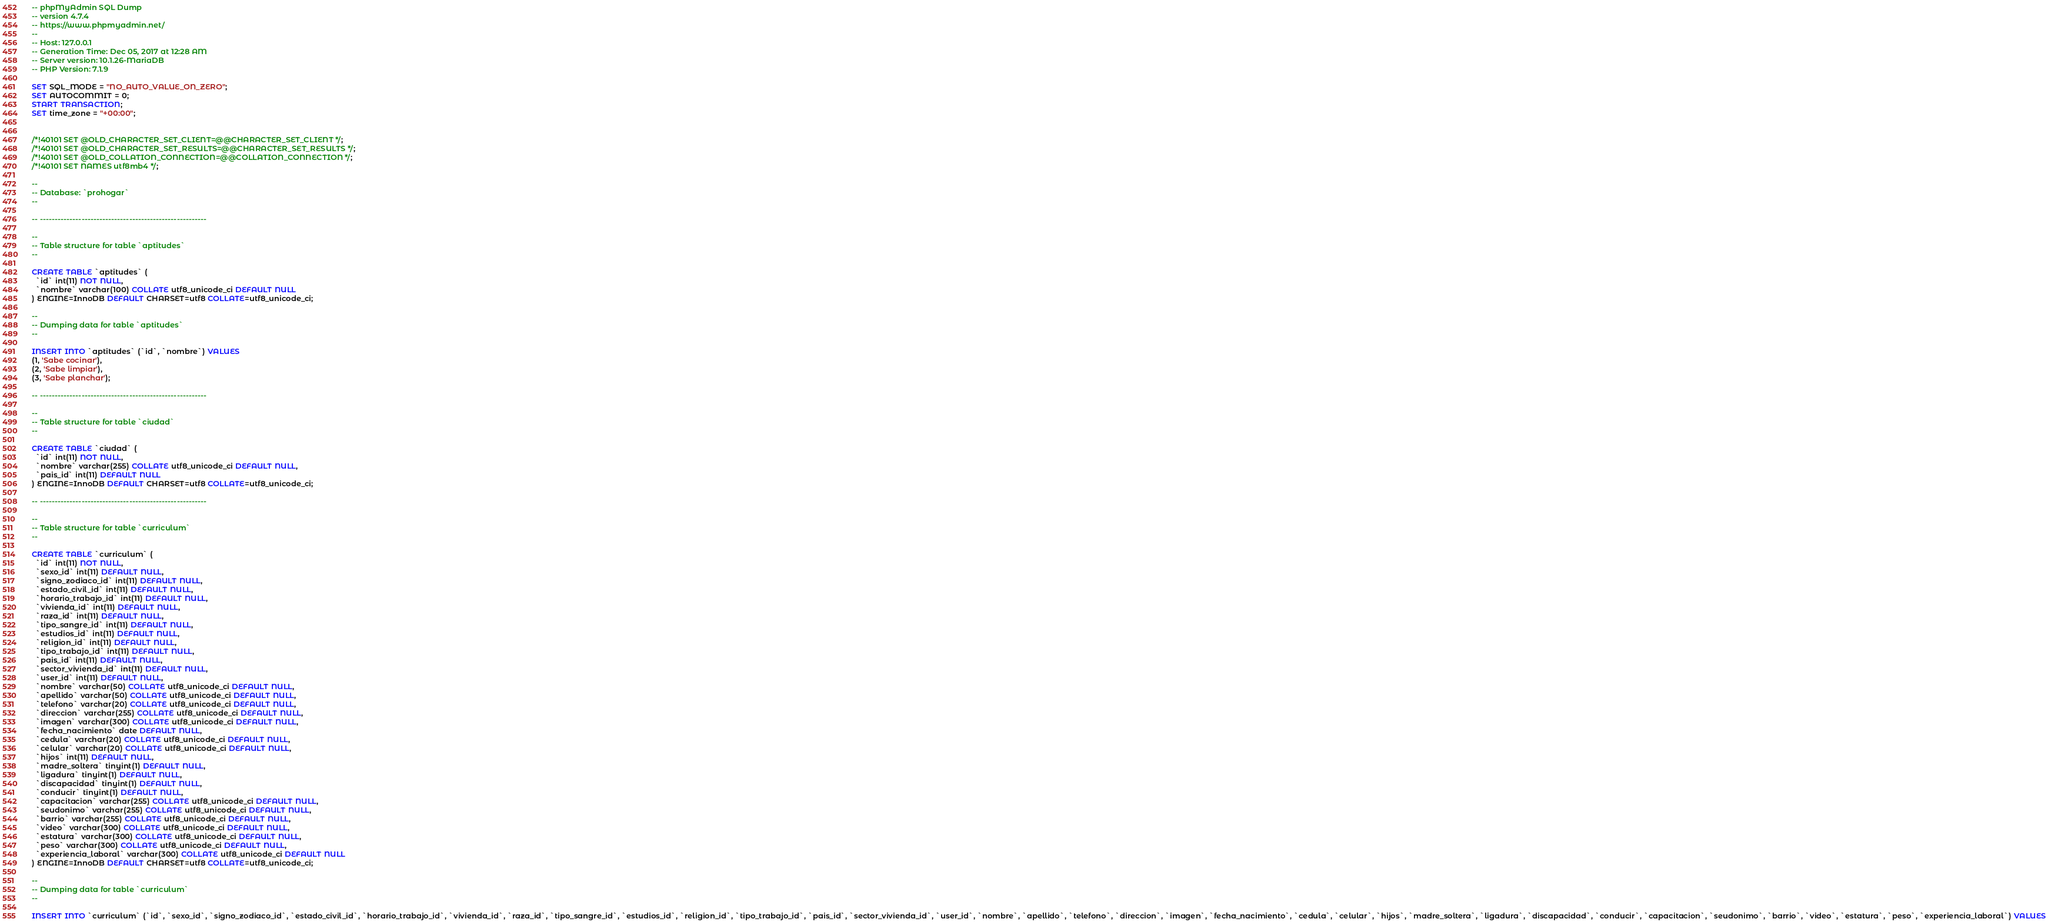<code> <loc_0><loc_0><loc_500><loc_500><_SQL_>-- phpMyAdmin SQL Dump
-- version 4.7.4
-- https://www.phpmyadmin.net/
--
-- Host: 127.0.0.1
-- Generation Time: Dec 05, 2017 at 12:28 AM
-- Server version: 10.1.26-MariaDB
-- PHP Version: 7.1.9

SET SQL_MODE = "NO_AUTO_VALUE_ON_ZERO";
SET AUTOCOMMIT = 0;
START TRANSACTION;
SET time_zone = "+00:00";


/*!40101 SET @OLD_CHARACTER_SET_CLIENT=@@CHARACTER_SET_CLIENT */;
/*!40101 SET @OLD_CHARACTER_SET_RESULTS=@@CHARACTER_SET_RESULTS */;
/*!40101 SET @OLD_COLLATION_CONNECTION=@@COLLATION_CONNECTION */;
/*!40101 SET NAMES utf8mb4 */;

--
-- Database: `prohogar`
--

-- --------------------------------------------------------

--
-- Table structure for table `aptitudes`
--

CREATE TABLE `aptitudes` (
  `id` int(11) NOT NULL,
  `nombre` varchar(100) COLLATE utf8_unicode_ci DEFAULT NULL
) ENGINE=InnoDB DEFAULT CHARSET=utf8 COLLATE=utf8_unicode_ci;

--
-- Dumping data for table `aptitudes`
--

INSERT INTO `aptitudes` (`id`, `nombre`) VALUES
(1, 'Sabe cocinar'),
(2, 'Sabe limpiar'),
(3, 'Sabe planchar');

-- --------------------------------------------------------

--
-- Table structure for table `ciudad`
--

CREATE TABLE `ciudad` (
  `id` int(11) NOT NULL,
  `nombre` varchar(255) COLLATE utf8_unicode_ci DEFAULT NULL,
  `pais_id` int(11) DEFAULT NULL
) ENGINE=InnoDB DEFAULT CHARSET=utf8 COLLATE=utf8_unicode_ci;

-- --------------------------------------------------------

--
-- Table structure for table `curriculum`
--

CREATE TABLE `curriculum` (
  `id` int(11) NOT NULL,
  `sexo_id` int(11) DEFAULT NULL,
  `signo_zodiaco_id` int(11) DEFAULT NULL,
  `estado_civil_id` int(11) DEFAULT NULL,
  `horario_trabajo_id` int(11) DEFAULT NULL,
  `vivienda_id` int(11) DEFAULT NULL,
  `raza_id` int(11) DEFAULT NULL,
  `tipo_sangre_id` int(11) DEFAULT NULL,
  `estudios_id` int(11) DEFAULT NULL,
  `religion_id` int(11) DEFAULT NULL,
  `tipo_trabajo_id` int(11) DEFAULT NULL,
  `pais_id` int(11) DEFAULT NULL,
  `sector_vivienda_id` int(11) DEFAULT NULL,
  `user_id` int(11) DEFAULT NULL,
  `nombre` varchar(50) COLLATE utf8_unicode_ci DEFAULT NULL,
  `apellido` varchar(50) COLLATE utf8_unicode_ci DEFAULT NULL,
  `telefono` varchar(20) COLLATE utf8_unicode_ci DEFAULT NULL,
  `direccion` varchar(255) COLLATE utf8_unicode_ci DEFAULT NULL,
  `imagen` varchar(300) COLLATE utf8_unicode_ci DEFAULT NULL,
  `fecha_nacimiento` date DEFAULT NULL,
  `cedula` varchar(20) COLLATE utf8_unicode_ci DEFAULT NULL,
  `celular` varchar(20) COLLATE utf8_unicode_ci DEFAULT NULL,
  `hijos` int(11) DEFAULT NULL,
  `madre_soltera` tinyint(1) DEFAULT NULL,
  `ligadura` tinyint(1) DEFAULT NULL,
  `discapacidad` tinyint(1) DEFAULT NULL,
  `conducir` tinyint(1) DEFAULT NULL,
  `capacitacion` varchar(255) COLLATE utf8_unicode_ci DEFAULT NULL,
  `seudonimo` varchar(255) COLLATE utf8_unicode_ci DEFAULT NULL,
  `barrio` varchar(255) COLLATE utf8_unicode_ci DEFAULT NULL,
  `video` varchar(300) COLLATE utf8_unicode_ci DEFAULT NULL,
  `estatura` varchar(300) COLLATE utf8_unicode_ci DEFAULT NULL,
  `peso` varchar(300) COLLATE utf8_unicode_ci DEFAULT NULL,
  `experiencia_laboral` varchar(300) COLLATE utf8_unicode_ci DEFAULT NULL
) ENGINE=InnoDB DEFAULT CHARSET=utf8 COLLATE=utf8_unicode_ci;

--
-- Dumping data for table `curriculum`
--

INSERT INTO `curriculum` (`id`, `sexo_id`, `signo_zodiaco_id`, `estado_civil_id`, `horario_trabajo_id`, `vivienda_id`, `raza_id`, `tipo_sangre_id`, `estudios_id`, `religion_id`, `tipo_trabajo_id`, `pais_id`, `sector_vivienda_id`, `user_id`, `nombre`, `apellido`, `telefono`, `direccion`, `imagen`, `fecha_nacimiento`, `cedula`, `celular`, `hijos`, `madre_soltera`, `ligadura`, `discapacidad`, `conducir`, `capacitacion`, `seudonimo`, `barrio`, `video`, `estatura`, `peso`, `experiencia_laboral`) VALUES</code> 